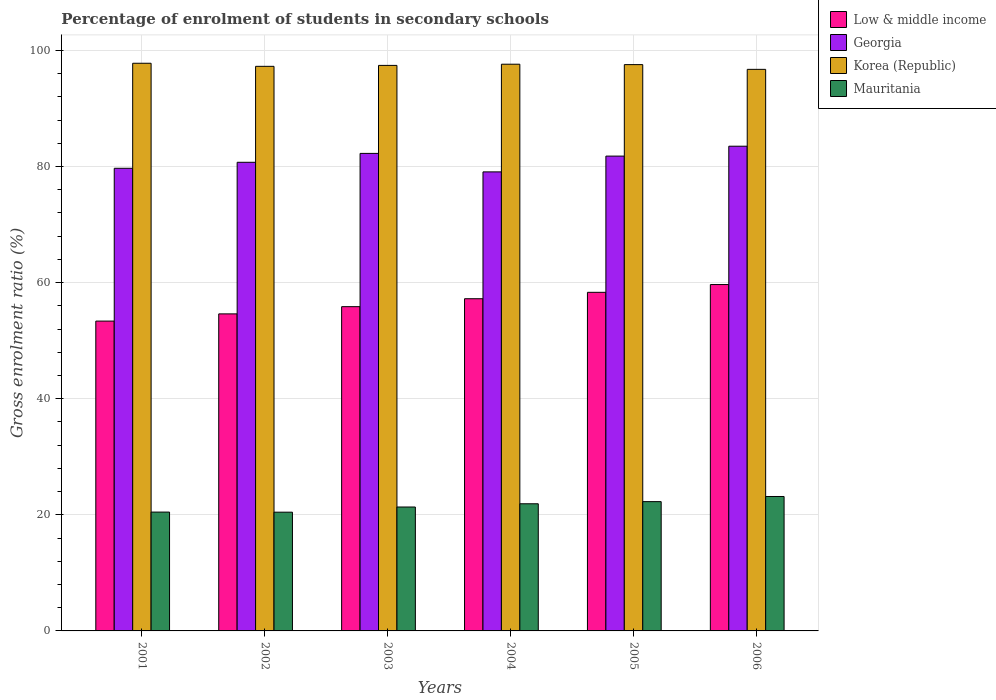Are the number of bars on each tick of the X-axis equal?
Your answer should be very brief. Yes. How many bars are there on the 4th tick from the right?
Make the answer very short. 4. In how many cases, is the number of bars for a given year not equal to the number of legend labels?
Make the answer very short. 0. What is the percentage of students enrolled in secondary schools in Korea (Republic) in 2002?
Your response must be concise. 97.24. Across all years, what is the maximum percentage of students enrolled in secondary schools in Mauritania?
Offer a terse response. 23.15. Across all years, what is the minimum percentage of students enrolled in secondary schools in Mauritania?
Make the answer very short. 20.45. In which year was the percentage of students enrolled in secondary schools in Low & middle income minimum?
Provide a short and direct response. 2001. What is the total percentage of students enrolled in secondary schools in Mauritania in the graph?
Your answer should be compact. 129.58. What is the difference between the percentage of students enrolled in secondary schools in Mauritania in 2003 and that in 2004?
Ensure brevity in your answer.  -0.56. What is the difference between the percentage of students enrolled in secondary schools in Mauritania in 2001 and the percentage of students enrolled in secondary schools in Korea (Republic) in 2006?
Give a very brief answer. -76.26. What is the average percentage of students enrolled in secondary schools in Mauritania per year?
Offer a very short reply. 21.6. In the year 2001, what is the difference between the percentage of students enrolled in secondary schools in Mauritania and percentage of students enrolled in secondary schools in Low & middle income?
Provide a short and direct response. -32.9. In how many years, is the percentage of students enrolled in secondary schools in Mauritania greater than 40 %?
Offer a very short reply. 0. What is the ratio of the percentage of students enrolled in secondary schools in Korea (Republic) in 2003 to that in 2006?
Provide a succinct answer. 1.01. What is the difference between the highest and the second highest percentage of students enrolled in secondary schools in Korea (Republic)?
Give a very brief answer. 0.16. What is the difference between the highest and the lowest percentage of students enrolled in secondary schools in Low & middle income?
Give a very brief answer. 6.29. In how many years, is the percentage of students enrolled in secondary schools in Korea (Republic) greater than the average percentage of students enrolled in secondary schools in Korea (Republic) taken over all years?
Your response must be concise. 4. Is the sum of the percentage of students enrolled in secondary schools in Low & middle income in 2003 and 2006 greater than the maximum percentage of students enrolled in secondary schools in Korea (Republic) across all years?
Give a very brief answer. Yes. Is it the case that in every year, the sum of the percentage of students enrolled in secondary schools in Mauritania and percentage of students enrolled in secondary schools in Korea (Republic) is greater than the sum of percentage of students enrolled in secondary schools in Georgia and percentage of students enrolled in secondary schools in Low & middle income?
Give a very brief answer. Yes. What does the 4th bar from the left in 2001 represents?
Give a very brief answer. Mauritania. What does the 1st bar from the right in 2003 represents?
Keep it short and to the point. Mauritania. Is it the case that in every year, the sum of the percentage of students enrolled in secondary schools in Georgia and percentage of students enrolled in secondary schools in Mauritania is greater than the percentage of students enrolled in secondary schools in Low & middle income?
Make the answer very short. Yes. Are all the bars in the graph horizontal?
Your answer should be very brief. No. How many years are there in the graph?
Provide a succinct answer. 6. What is the difference between two consecutive major ticks on the Y-axis?
Provide a short and direct response. 20. Where does the legend appear in the graph?
Ensure brevity in your answer.  Top right. How many legend labels are there?
Keep it short and to the point. 4. What is the title of the graph?
Your answer should be very brief. Percentage of enrolment of students in secondary schools. What is the Gross enrolment ratio (%) of Low & middle income in 2001?
Make the answer very short. 53.37. What is the Gross enrolment ratio (%) of Georgia in 2001?
Your answer should be very brief. 79.68. What is the Gross enrolment ratio (%) in Korea (Republic) in 2001?
Offer a terse response. 97.77. What is the Gross enrolment ratio (%) in Mauritania in 2001?
Offer a very short reply. 20.47. What is the Gross enrolment ratio (%) of Low & middle income in 2002?
Offer a terse response. 54.61. What is the Gross enrolment ratio (%) of Georgia in 2002?
Your answer should be compact. 80.72. What is the Gross enrolment ratio (%) in Korea (Republic) in 2002?
Ensure brevity in your answer.  97.24. What is the Gross enrolment ratio (%) in Mauritania in 2002?
Ensure brevity in your answer.  20.45. What is the Gross enrolment ratio (%) of Low & middle income in 2003?
Your response must be concise. 55.85. What is the Gross enrolment ratio (%) in Georgia in 2003?
Your answer should be very brief. 82.25. What is the Gross enrolment ratio (%) of Korea (Republic) in 2003?
Ensure brevity in your answer.  97.4. What is the Gross enrolment ratio (%) of Mauritania in 2003?
Provide a short and direct response. 21.34. What is the Gross enrolment ratio (%) in Low & middle income in 2004?
Give a very brief answer. 57.22. What is the Gross enrolment ratio (%) of Georgia in 2004?
Offer a terse response. 79.06. What is the Gross enrolment ratio (%) in Korea (Republic) in 2004?
Provide a short and direct response. 97.61. What is the Gross enrolment ratio (%) of Mauritania in 2004?
Ensure brevity in your answer.  21.9. What is the Gross enrolment ratio (%) of Low & middle income in 2005?
Ensure brevity in your answer.  58.32. What is the Gross enrolment ratio (%) in Georgia in 2005?
Provide a short and direct response. 81.78. What is the Gross enrolment ratio (%) of Korea (Republic) in 2005?
Give a very brief answer. 97.54. What is the Gross enrolment ratio (%) in Mauritania in 2005?
Keep it short and to the point. 22.27. What is the Gross enrolment ratio (%) of Low & middle income in 2006?
Provide a short and direct response. 59.66. What is the Gross enrolment ratio (%) of Georgia in 2006?
Offer a very short reply. 83.49. What is the Gross enrolment ratio (%) of Korea (Republic) in 2006?
Make the answer very short. 96.72. What is the Gross enrolment ratio (%) in Mauritania in 2006?
Give a very brief answer. 23.15. Across all years, what is the maximum Gross enrolment ratio (%) in Low & middle income?
Provide a short and direct response. 59.66. Across all years, what is the maximum Gross enrolment ratio (%) in Georgia?
Your answer should be compact. 83.49. Across all years, what is the maximum Gross enrolment ratio (%) of Korea (Republic)?
Provide a short and direct response. 97.77. Across all years, what is the maximum Gross enrolment ratio (%) of Mauritania?
Offer a very short reply. 23.15. Across all years, what is the minimum Gross enrolment ratio (%) of Low & middle income?
Your answer should be very brief. 53.37. Across all years, what is the minimum Gross enrolment ratio (%) in Georgia?
Keep it short and to the point. 79.06. Across all years, what is the minimum Gross enrolment ratio (%) of Korea (Republic)?
Provide a succinct answer. 96.72. Across all years, what is the minimum Gross enrolment ratio (%) of Mauritania?
Offer a terse response. 20.45. What is the total Gross enrolment ratio (%) in Low & middle income in the graph?
Give a very brief answer. 339.02. What is the total Gross enrolment ratio (%) in Georgia in the graph?
Give a very brief answer. 486.98. What is the total Gross enrolment ratio (%) of Korea (Republic) in the graph?
Provide a succinct answer. 584.29. What is the total Gross enrolment ratio (%) of Mauritania in the graph?
Make the answer very short. 129.58. What is the difference between the Gross enrolment ratio (%) of Low & middle income in 2001 and that in 2002?
Ensure brevity in your answer.  -1.24. What is the difference between the Gross enrolment ratio (%) of Georgia in 2001 and that in 2002?
Keep it short and to the point. -1.04. What is the difference between the Gross enrolment ratio (%) of Korea (Republic) in 2001 and that in 2002?
Keep it short and to the point. 0.53. What is the difference between the Gross enrolment ratio (%) in Mauritania in 2001 and that in 2002?
Provide a short and direct response. 0.02. What is the difference between the Gross enrolment ratio (%) in Low & middle income in 2001 and that in 2003?
Make the answer very short. -2.48. What is the difference between the Gross enrolment ratio (%) of Georgia in 2001 and that in 2003?
Make the answer very short. -2.57. What is the difference between the Gross enrolment ratio (%) of Korea (Republic) in 2001 and that in 2003?
Make the answer very short. 0.37. What is the difference between the Gross enrolment ratio (%) in Mauritania in 2001 and that in 2003?
Ensure brevity in your answer.  -0.87. What is the difference between the Gross enrolment ratio (%) in Low & middle income in 2001 and that in 2004?
Provide a short and direct response. -3.85. What is the difference between the Gross enrolment ratio (%) of Georgia in 2001 and that in 2004?
Your answer should be very brief. 0.62. What is the difference between the Gross enrolment ratio (%) of Korea (Republic) in 2001 and that in 2004?
Ensure brevity in your answer.  0.16. What is the difference between the Gross enrolment ratio (%) of Mauritania in 2001 and that in 2004?
Provide a short and direct response. -1.43. What is the difference between the Gross enrolment ratio (%) in Low & middle income in 2001 and that in 2005?
Make the answer very short. -4.95. What is the difference between the Gross enrolment ratio (%) in Georgia in 2001 and that in 2005?
Offer a terse response. -2.1. What is the difference between the Gross enrolment ratio (%) of Korea (Republic) in 2001 and that in 2005?
Make the answer very short. 0.23. What is the difference between the Gross enrolment ratio (%) of Mauritania in 2001 and that in 2005?
Offer a terse response. -1.8. What is the difference between the Gross enrolment ratio (%) in Low & middle income in 2001 and that in 2006?
Offer a terse response. -6.29. What is the difference between the Gross enrolment ratio (%) of Georgia in 2001 and that in 2006?
Give a very brief answer. -3.8. What is the difference between the Gross enrolment ratio (%) of Korea (Republic) in 2001 and that in 2006?
Ensure brevity in your answer.  1.05. What is the difference between the Gross enrolment ratio (%) in Mauritania in 2001 and that in 2006?
Make the answer very short. -2.68. What is the difference between the Gross enrolment ratio (%) in Low & middle income in 2002 and that in 2003?
Make the answer very short. -1.24. What is the difference between the Gross enrolment ratio (%) in Georgia in 2002 and that in 2003?
Give a very brief answer. -1.53. What is the difference between the Gross enrolment ratio (%) of Korea (Republic) in 2002 and that in 2003?
Your answer should be compact. -0.16. What is the difference between the Gross enrolment ratio (%) in Mauritania in 2002 and that in 2003?
Keep it short and to the point. -0.89. What is the difference between the Gross enrolment ratio (%) of Low & middle income in 2002 and that in 2004?
Make the answer very short. -2.61. What is the difference between the Gross enrolment ratio (%) of Georgia in 2002 and that in 2004?
Your response must be concise. 1.65. What is the difference between the Gross enrolment ratio (%) of Korea (Republic) in 2002 and that in 2004?
Keep it short and to the point. -0.37. What is the difference between the Gross enrolment ratio (%) of Mauritania in 2002 and that in 2004?
Offer a terse response. -1.45. What is the difference between the Gross enrolment ratio (%) in Low & middle income in 2002 and that in 2005?
Provide a short and direct response. -3.71. What is the difference between the Gross enrolment ratio (%) in Georgia in 2002 and that in 2005?
Give a very brief answer. -1.07. What is the difference between the Gross enrolment ratio (%) in Korea (Republic) in 2002 and that in 2005?
Keep it short and to the point. -0.3. What is the difference between the Gross enrolment ratio (%) of Mauritania in 2002 and that in 2005?
Make the answer very short. -1.82. What is the difference between the Gross enrolment ratio (%) in Low & middle income in 2002 and that in 2006?
Give a very brief answer. -5.05. What is the difference between the Gross enrolment ratio (%) of Georgia in 2002 and that in 2006?
Give a very brief answer. -2.77. What is the difference between the Gross enrolment ratio (%) in Korea (Republic) in 2002 and that in 2006?
Your answer should be compact. 0.52. What is the difference between the Gross enrolment ratio (%) of Mauritania in 2002 and that in 2006?
Give a very brief answer. -2.7. What is the difference between the Gross enrolment ratio (%) in Low & middle income in 2003 and that in 2004?
Your response must be concise. -1.37. What is the difference between the Gross enrolment ratio (%) in Georgia in 2003 and that in 2004?
Your answer should be very brief. 3.19. What is the difference between the Gross enrolment ratio (%) in Korea (Republic) in 2003 and that in 2004?
Offer a terse response. -0.2. What is the difference between the Gross enrolment ratio (%) in Mauritania in 2003 and that in 2004?
Provide a short and direct response. -0.56. What is the difference between the Gross enrolment ratio (%) in Low & middle income in 2003 and that in 2005?
Ensure brevity in your answer.  -2.47. What is the difference between the Gross enrolment ratio (%) of Georgia in 2003 and that in 2005?
Your answer should be compact. 0.47. What is the difference between the Gross enrolment ratio (%) in Korea (Republic) in 2003 and that in 2005?
Offer a terse response. -0.13. What is the difference between the Gross enrolment ratio (%) of Mauritania in 2003 and that in 2005?
Your answer should be very brief. -0.93. What is the difference between the Gross enrolment ratio (%) of Low & middle income in 2003 and that in 2006?
Make the answer very short. -3.81. What is the difference between the Gross enrolment ratio (%) of Georgia in 2003 and that in 2006?
Offer a terse response. -1.24. What is the difference between the Gross enrolment ratio (%) in Korea (Republic) in 2003 and that in 2006?
Keep it short and to the point. 0.68. What is the difference between the Gross enrolment ratio (%) of Mauritania in 2003 and that in 2006?
Make the answer very short. -1.81. What is the difference between the Gross enrolment ratio (%) of Low & middle income in 2004 and that in 2005?
Provide a short and direct response. -1.1. What is the difference between the Gross enrolment ratio (%) in Georgia in 2004 and that in 2005?
Ensure brevity in your answer.  -2.72. What is the difference between the Gross enrolment ratio (%) of Korea (Republic) in 2004 and that in 2005?
Make the answer very short. 0.07. What is the difference between the Gross enrolment ratio (%) of Mauritania in 2004 and that in 2005?
Your response must be concise. -0.37. What is the difference between the Gross enrolment ratio (%) of Low & middle income in 2004 and that in 2006?
Provide a succinct answer. -2.44. What is the difference between the Gross enrolment ratio (%) of Georgia in 2004 and that in 2006?
Offer a very short reply. -4.42. What is the difference between the Gross enrolment ratio (%) of Korea (Republic) in 2004 and that in 2006?
Make the answer very short. 0.88. What is the difference between the Gross enrolment ratio (%) in Mauritania in 2004 and that in 2006?
Offer a very short reply. -1.25. What is the difference between the Gross enrolment ratio (%) in Low & middle income in 2005 and that in 2006?
Provide a succinct answer. -1.34. What is the difference between the Gross enrolment ratio (%) of Georgia in 2005 and that in 2006?
Offer a very short reply. -1.7. What is the difference between the Gross enrolment ratio (%) of Korea (Republic) in 2005 and that in 2006?
Make the answer very short. 0.81. What is the difference between the Gross enrolment ratio (%) in Mauritania in 2005 and that in 2006?
Your answer should be very brief. -0.89. What is the difference between the Gross enrolment ratio (%) in Low & middle income in 2001 and the Gross enrolment ratio (%) in Georgia in 2002?
Give a very brief answer. -27.35. What is the difference between the Gross enrolment ratio (%) in Low & middle income in 2001 and the Gross enrolment ratio (%) in Korea (Republic) in 2002?
Offer a very short reply. -43.88. What is the difference between the Gross enrolment ratio (%) in Low & middle income in 2001 and the Gross enrolment ratio (%) in Mauritania in 2002?
Offer a very short reply. 32.91. What is the difference between the Gross enrolment ratio (%) in Georgia in 2001 and the Gross enrolment ratio (%) in Korea (Republic) in 2002?
Ensure brevity in your answer.  -17.56. What is the difference between the Gross enrolment ratio (%) in Georgia in 2001 and the Gross enrolment ratio (%) in Mauritania in 2002?
Provide a short and direct response. 59.23. What is the difference between the Gross enrolment ratio (%) of Korea (Republic) in 2001 and the Gross enrolment ratio (%) of Mauritania in 2002?
Provide a succinct answer. 77.32. What is the difference between the Gross enrolment ratio (%) of Low & middle income in 2001 and the Gross enrolment ratio (%) of Georgia in 2003?
Provide a succinct answer. -28.88. What is the difference between the Gross enrolment ratio (%) in Low & middle income in 2001 and the Gross enrolment ratio (%) in Korea (Republic) in 2003?
Ensure brevity in your answer.  -44.04. What is the difference between the Gross enrolment ratio (%) in Low & middle income in 2001 and the Gross enrolment ratio (%) in Mauritania in 2003?
Give a very brief answer. 32.02. What is the difference between the Gross enrolment ratio (%) in Georgia in 2001 and the Gross enrolment ratio (%) in Korea (Republic) in 2003?
Provide a succinct answer. -17.72. What is the difference between the Gross enrolment ratio (%) of Georgia in 2001 and the Gross enrolment ratio (%) of Mauritania in 2003?
Keep it short and to the point. 58.34. What is the difference between the Gross enrolment ratio (%) in Korea (Republic) in 2001 and the Gross enrolment ratio (%) in Mauritania in 2003?
Your answer should be very brief. 76.43. What is the difference between the Gross enrolment ratio (%) in Low & middle income in 2001 and the Gross enrolment ratio (%) in Georgia in 2004?
Give a very brief answer. -25.7. What is the difference between the Gross enrolment ratio (%) of Low & middle income in 2001 and the Gross enrolment ratio (%) of Korea (Republic) in 2004?
Ensure brevity in your answer.  -44.24. What is the difference between the Gross enrolment ratio (%) in Low & middle income in 2001 and the Gross enrolment ratio (%) in Mauritania in 2004?
Give a very brief answer. 31.47. What is the difference between the Gross enrolment ratio (%) in Georgia in 2001 and the Gross enrolment ratio (%) in Korea (Republic) in 2004?
Provide a succinct answer. -17.93. What is the difference between the Gross enrolment ratio (%) in Georgia in 2001 and the Gross enrolment ratio (%) in Mauritania in 2004?
Keep it short and to the point. 57.78. What is the difference between the Gross enrolment ratio (%) of Korea (Republic) in 2001 and the Gross enrolment ratio (%) of Mauritania in 2004?
Provide a short and direct response. 75.87. What is the difference between the Gross enrolment ratio (%) of Low & middle income in 2001 and the Gross enrolment ratio (%) of Georgia in 2005?
Your answer should be very brief. -28.42. What is the difference between the Gross enrolment ratio (%) in Low & middle income in 2001 and the Gross enrolment ratio (%) in Korea (Republic) in 2005?
Your response must be concise. -44.17. What is the difference between the Gross enrolment ratio (%) in Low & middle income in 2001 and the Gross enrolment ratio (%) in Mauritania in 2005?
Keep it short and to the point. 31.1. What is the difference between the Gross enrolment ratio (%) of Georgia in 2001 and the Gross enrolment ratio (%) of Korea (Republic) in 2005?
Offer a very short reply. -17.86. What is the difference between the Gross enrolment ratio (%) of Georgia in 2001 and the Gross enrolment ratio (%) of Mauritania in 2005?
Make the answer very short. 57.41. What is the difference between the Gross enrolment ratio (%) of Korea (Republic) in 2001 and the Gross enrolment ratio (%) of Mauritania in 2005?
Your answer should be compact. 75.51. What is the difference between the Gross enrolment ratio (%) of Low & middle income in 2001 and the Gross enrolment ratio (%) of Georgia in 2006?
Keep it short and to the point. -30.12. What is the difference between the Gross enrolment ratio (%) of Low & middle income in 2001 and the Gross enrolment ratio (%) of Korea (Republic) in 2006?
Keep it short and to the point. -43.36. What is the difference between the Gross enrolment ratio (%) of Low & middle income in 2001 and the Gross enrolment ratio (%) of Mauritania in 2006?
Provide a succinct answer. 30.21. What is the difference between the Gross enrolment ratio (%) of Georgia in 2001 and the Gross enrolment ratio (%) of Korea (Republic) in 2006?
Your answer should be very brief. -17.04. What is the difference between the Gross enrolment ratio (%) of Georgia in 2001 and the Gross enrolment ratio (%) of Mauritania in 2006?
Give a very brief answer. 56.53. What is the difference between the Gross enrolment ratio (%) in Korea (Republic) in 2001 and the Gross enrolment ratio (%) in Mauritania in 2006?
Offer a very short reply. 74.62. What is the difference between the Gross enrolment ratio (%) of Low & middle income in 2002 and the Gross enrolment ratio (%) of Georgia in 2003?
Keep it short and to the point. -27.64. What is the difference between the Gross enrolment ratio (%) of Low & middle income in 2002 and the Gross enrolment ratio (%) of Korea (Republic) in 2003?
Your response must be concise. -42.8. What is the difference between the Gross enrolment ratio (%) of Low & middle income in 2002 and the Gross enrolment ratio (%) of Mauritania in 2003?
Make the answer very short. 33.26. What is the difference between the Gross enrolment ratio (%) in Georgia in 2002 and the Gross enrolment ratio (%) in Korea (Republic) in 2003?
Make the answer very short. -16.69. What is the difference between the Gross enrolment ratio (%) in Georgia in 2002 and the Gross enrolment ratio (%) in Mauritania in 2003?
Offer a terse response. 59.37. What is the difference between the Gross enrolment ratio (%) in Korea (Republic) in 2002 and the Gross enrolment ratio (%) in Mauritania in 2003?
Make the answer very short. 75.9. What is the difference between the Gross enrolment ratio (%) of Low & middle income in 2002 and the Gross enrolment ratio (%) of Georgia in 2004?
Make the answer very short. -24.46. What is the difference between the Gross enrolment ratio (%) of Low & middle income in 2002 and the Gross enrolment ratio (%) of Korea (Republic) in 2004?
Your response must be concise. -43. What is the difference between the Gross enrolment ratio (%) of Low & middle income in 2002 and the Gross enrolment ratio (%) of Mauritania in 2004?
Ensure brevity in your answer.  32.71. What is the difference between the Gross enrolment ratio (%) in Georgia in 2002 and the Gross enrolment ratio (%) in Korea (Republic) in 2004?
Your answer should be very brief. -16.89. What is the difference between the Gross enrolment ratio (%) in Georgia in 2002 and the Gross enrolment ratio (%) in Mauritania in 2004?
Provide a succinct answer. 58.82. What is the difference between the Gross enrolment ratio (%) in Korea (Republic) in 2002 and the Gross enrolment ratio (%) in Mauritania in 2004?
Offer a terse response. 75.34. What is the difference between the Gross enrolment ratio (%) in Low & middle income in 2002 and the Gross enrolment ratio (%) in Georgia in 2005?
Keep it short and to the point. -27.18. What is the difference between the Gross enrolment ratio (%) in Low & middle income in 2002 and the Gross enrolment ratio (%) in Korea (Republic) in 2005?
Give a very brief answer. -42.93. What is the difference between the Gross enrolment ratio (%) in Low & middle income in 2002 and the Gross enrolment ratio (%) in Mauritania in 2005?
Keep it short and to the point. 32.34. What is the difference between the Gross enrolment ratio (%) in Georgia in 2002 and the Gross enrolment ratio (%) in Korea (Republic) in 2005?
Make the answer very short. -16.82. What is the difference between the Gross enrolment ratio (%) of Georgia in 2002 and the Gross enrolment ratio (%) of Mauritania in 2005?
Your answer should be compact. 58.45. What is the difference between the Gross enrolment ratio (%) of Korea (Republic) in 2002 and the Gross enrolment ratio (%) of Mauritania in 2005?
Provide a short and direct response. 74.98. What is the difference between the Gross enrolment ratio (%) of Low & middle income in 2002 and the Gross enrolment ratio (%) of Georgia in 2006?
Offer a very short reply. -28.88. What is the difference between the Gross enrolment ratio (%) in Low & middle income in 2002 and the Gross enrolment ratio (%) in Korea (Republic) in 2006?
Your answer should be very brief. -42.12. What is the difference between the Gross enrolment ratio (%) of Low & middle income in 2002 and the Gross enrolment ratio (%) of Mauritania in 2006?
Keep it short and to the point. 31.45. What is the difference between the Gross enrolment ratio (%) of Georgia in 2002 and the Gross enrolment ratio (%) of Korea (Republic) in 2006?
Your response must be concise. -16.01. What is the difference between the Gross enrolment ratio (%) of Georgia in 2002 and the Gross enrolment ratio (%) of Mauritania in 2006?
Your answer should be very brief. 57.56. What is the difference between the Gross enrolment ratio (%) in Korea (Republic) in 2002 and the Gross enrolment ratio (%) in Mauritania in 2006?
Provide a succinct answer. 74.09. What is the difference between the Gross enrolment ratio (%) in Low & middle income in 2003 and the Gross enrolment ratio (%) in Georgia in 2004?
Your answer should be very brief. -23.21. What is the difference between the Gross enrolment ratio (%) of Low & middle income in 2003 and the Gross enrolment ratio (%) of Korea (Republic) in 2004?
Your response must be concise. -41.76. What is the difference between the Gross enrolment ratio (%) of Low & middle income in 2003 and the Gross enrolment ratio (%) of Mauritania in 2004?
Provide a succinct answer. 33.95. What is the difference between the Gross enrolment ratio (%) of Georgia in 2003 and the Gross enrolment ratio (%) of Korea (Republic) in 2004?
Provide a short and direct response. -15.36. What is the difference between the Gross enrolment ratio (%) in Georgia in 2003 and the Gross enrolment ratio (%) in Mauritania in 2004?
Your response must be concise. 60.35. What is the difference between the Gross enrolment ratio (%) of Korea (Republic) in 2003 and the Gross enrolment ratio (%) of Mauritania in 2004?
Ensure brevity in your answer.  75.51. What is the difference between the Gross enrolment ratio (%) of Low & middle income in 2003 and the Gross enrolment ratio (%) of Georgia in 2005?
Offer a very short reply. -25.93. What is the difference between the Gross enrolment ratio (%) of Low & middle income in 2003 and the Gross enrolment ratio (%) of Korea (Republic) in 2005?
Provide a short and direct response. -41.69. What is the difference between the Gross enrolment ratio (%) of Low & middle income in 2003 and the Gross enrolment ratio (%) of Mauritania in 2005?
Your answer should be compact. 33.58. What is the difference between the Gross enrolment ratio (%) of Georgia in 2003 and the Gross enrolment ratio (%) of Korea (Republic) in 2005?
Make the answer very short. -15.29. What is the difference between the Gross enrolment ratio (%) of Georgia in 2003 and the Gross enrolment ratio (%) of Mauritania in 2005?
Give a very brief answer. 59.98. What is the difference between the Gross enrolment ratio (%) of Korea (Republic) in 2003 and the Gross enrolment ratio (%) of Mauritania in 2005?
Keep it short and to the point. 75.14. What is the difference between the Gross enrolment ratio (%) in Low & middle income in 2003 and the Gross enrolment ratio (%) in Georgia in 2006?
Provide a short and direct response. -27.64. What is the difference between the Gross enrolment ratio (%) in Low & middle income in 2003 and the Gross enrolment ratio (%) in Korea (Republic) in 2006?
Make the answer very short. -40.88. What is the difference between the Gross enrolment ratio (%) of Low & middle income in 2003 and the Gross enrolment ratio (%) of Mauritania in 2006?
Keep it short and to the point. 32.7. What is the difference between the Gross enrolment ratio (%) in Georgia in 2003 and the Gross enrolment ratio (%) in Korea (Republic) in 2006?
Keep it short and to the point. -14.48. What is the difference between the Gross enrolment ratio (%) in Georgia in 2003 and the Gross enrolment ratio (%) in Mauritania in 2006?
Offer a very short reply. 59.1. What is the difference between the Gross enrolment ratio (%) of Korea (Republic) in 2003 and the Gross enrolment ratio (%) of Mauritania in 2006?
Give a very brief answer. 74.25. What is the difference between the Gross enrolment ratio (%) of Low & middle income in 2004 and the Gross enrolment ratio (%) of Georgia in 2005?
Your response must be concise. -24.56. What is the difference between the Gross enrolment ratio (%) in Low & middle income in 2004 and the Gross enrolment ratio (%) in Korea (Republic) in 2005?
Make the answer very short. -40.32. What is the difference between the Gross enrolment ratio (%) of Low & middle income in 2004 and the Gross enrolment ratio (%) of Mauritania in 2005?
Ensure brevity in your answer.  34.95. What is the difference between the Gross enrolment ratio (%) of Georgia in 2004 and the Gross enrolment ratio (%) of Korea (Republic) in 2005?
Keep it short and to the point. -18.48. What is the difference between the Gross enrolment ratio (%) in Georgia in 2004 and the Gross enrolment ratio (%) in Mauritania in 2005?
Make the answer very short. 56.8. What is the difference between the Gross enrolment ratio (%) of Korea (Republic) in 2004 and the Gross enrolment ratio (%) of Mauritania in 2005?
Your answer should be very brief. 75.34. What is the difference between the Gross enrolment ratio (%) in Low & middle income in 2004 and the Gross enrolment ratio (%) in Georgia in 2006?
Ensure brevity in your answer.  -26.27. What is the difference between the Gross enrolment ratio (%) in Low & middle income in 2004 and the Gross enrolment ratio (%) in Korea (Republic) in 2006?
Make the answer very short. -39.51. What is the difference between the Gross enrolment ratio (%) of Low & middle income in 2004 and the Gross enrolment ratio (%) of Mauritania in 2006?
Provide a short and direct response. 34.06. What is the difference between the Gross enrolment ratio (%) of Georgia in 2004 and the Gross enrolment ratio (%) of Korea (Republic) in 2006?
Give a very brief answer. -17.66. What is the difference between the Gross enrolment ratio (%) in Georgia in 2004 and the Gross enrolment ratio (%) in Mauritania in 2006?
Provide a short and direct response. 55.91. What is the difference between the Gross enrolment ratio (%) of Korea (Republic) in 2004 and the Gross enrolment ratio (%) of Mauritania in 2006?
Provide a succinct answer. 74.46. What is the difference between the Gross enrolment ratio (%) in Low & middle income in 2005 and the Gross enrolment ratio (%) in Georgia in 2006?
Provide a short and direct response. -25.17. What is the difference between the Gross enrolment ratio (%) in Low & middle income in 2005 and the Gross enrolment ratio (%) in Korea (Republic) in 2006?
Ensure brevity in your answer.  -38.4. What is the difference between the Gross enrolment ratio (%) in Low & middle income in 2005 and the Gross enrolment ratio (%) in Mauritania in 2006?
Your answer should be compact. 35.17. What is the difference between the Gross enrolment ratio (%) in Georgia in 2005 and the Gross enrolment ratio (%) in Korea (Republic) in 2006?
Ensure brevity in your answer.  -14.94. What is the difference between the Gross enrolment ratio (%) of Georgia in 2005 and the Gross enrolment ratio (%) of Mauritania in 2006?
Your answer should be compact. 58.63. What is the difference between the Gross enrolment ratio (%) of Korea (Republic) in 2005 and the Gross enrolment ratio (%) of Mauritania in 2006?
Ensure brevity in your answer.  74.39. What is the average Gross enrolment ratio (%) of Low & middle income per year?
Offer a very short reply. 56.5. What is the average Gross enrolment ratio (%) in Georgia per year?
Your answer should be very brief. 81.16. What is the average Gross enrolment ratio (%) of Korea (Republic) per year?
Your answer should be compact. 97.38. What is the average Gross enrolment ratio (%) of Mauritania per year?
Your answer should be compact. 21.6. In the year 2001, what is the difference between the Gross enrolment ratio (%) of Low & middle income and Gross enrolment ratio (%) of Georgia?
Keep it short and to the point. -26.32. In the year 2001, what is the difference between the Gross enrolment ratio (%) in Low & middle income and Gross enrolment ratio (%) in Korea (Republic)?
Offer a very short reply. -44.41. In the year 2001, what is the difference between the Gross enrolment ratio (%) of Low & middle income and Gross enrolment ratio (%) of Mauritania?
Offer a terse response. 32.9. In the year 2001, what is the difference between the Gross enrolment ratio (%) of Georgia and Gross enrolment ratio (%) of Korea (Republic)?
Make the answer very short. -18.09. In the year 2001, what is the difference between the Gross enrolment ratio (%) in Georgia and Gross enrolment ratio (%) in Mauritania?
Provide a short and direct response. 59.21. In the year 2001, what is the difference between the Gross enrolment ratio (%) in Korea (Republic) and Gross enrolment ratio (%) in Mauritania?
Keep it short and to the point. 77.3. In the year 2002, what is the difference between the Gross enrolment ratio (%) of Low & middle income and Gross enrolment ratio (%) of Georgia?
Provide a succinct answer. -26.11. In the year 2002, what is the difference between the Gross enrolment ratio (%) in Low & middle income and Gross enrolment ratio (%) in Korea (Republic)?
Offer a terse response. -42.64. In the year 2002, what is the difference between the Gross enrolment ratio (%) in Low & middle income and Gross enrolment ratio (%) in Mauritania?
Ensure brevity in your answer.  34.15. In the year 2002, what is the difference between the Gross enrolment ratio (%) of Georgia and Gross enrolment ratio (%) of Korea (Republic)?
Give a very brief answer. -16.53. In the year 2002, what is the difference between the Gross enrolment ratio (%) in Georgia and Gross enrolment ratio (%) in Mauritania?
Provide a succinct answer. 60.27. In the year 2002, what is the difference between the Gross enrolment ratio (%) of Korea (Republic) and Gross enrolment ratio (%) of Mauritania?
Your answer should be very brief. 76.79. In the year 2003, what is the difference between the Gross enrolment ratio (%) in Low & middle income and Gross enrolment ratio (%) in Georgia?
Your response must be concise. -26.4. In the year 2003, what is the difference between the Gross enrolment ratio (%) in Low & middle income and Gross enrolment ratio (%) in Korea (Republic)?
Give a very brief answer. -41.56. In the year 2003, what is the difference between the Gross enrolment ratio (%) of Low & middle income and Gross enrolment ratio (%) of Mauritania?
Provide a succinct answer. 34.51. In the year 2003, what is the difference between the Gross enrolment ratio (%) of Georgia and Gross enrolment ratio (%) of Korea (Republic)?
Give a very brief answer. -15.16. In the year 2003, what is the difference between the Gross enrolment ratio (%) in Georgia and Gross enrolment ratio (%) in Mauritania?
Your answer should be compact. 60.91. In the year 2003, what is the difference between the Gross enrolment ratio (%) of Korea (Republic) and Gross enrolment ratio (%) of Mauritania?
Provide a succinct answer. 76.06. In the year 2004, what is the difference between the Gross enrolment ratio (%) in Low & middle income and Gross enrolment ratio (%) in Georgia?
Give a very brief answer. -21.85. In the year 2004, what is the difference between the Gross enrolment ratio (%) in Low & middle income and Gross enrolment ratio (%) in Korea (Republic)?
Your response must be concise. -40.39. In the year 2004, what is the difference between the Gross enrolment ratio (%) in Low & middle income and Gross enrolment ratio (%) in Mauritania?
Keep it short and to the point. 35.32. In the year 2004, what is the difference between the Gross enrolment ratio (%) in Georgia and Gross enrolment ratio (%) in Korea (Republic)?
Your response must be concise. -18.55. In the year 2004, what is the difference between the Gross enrolment ratio (%) in Georgia and Gross enrolment ratio (%) in Mauritania?
Make the answer very short. 57.16. In the year 2004, what is the difference between the Gross enrolment ratio (%) in Korea (Republic) and Gross enrolment ratio (%) in Mauritania?
Your answer should be compact. 75.71. In the year 2005, what is the difference between the Gross enrolment ratio (%) of Low & middle income and Gross enrolment ratio (%) of Georgia?
Ensure brevity in your answer.  -23.46. In the year 2005, what is the difference between the Gross enrolment ratio (%) in Low & middle income and Gross enrolment ratio (%) in Korea (Republic)?
Ensure brevity in your answer.  -39.22. In the year 2005, what is the difference between the Gross enrolment ratio (%) of Low & middle income and Gross enrolment ratio (%) of Mauritania?
Provide a succinct answer. 36.05. In the year 2005, what is the difference between the Gross enrolment ratio (%) in Georgia and Gross enrolment ratio (%) in Korea (Republic)?
Provide a short and direct response. -15.76. In the year 2005, what is the difference between the Gross enrolment ratio (%) in Georgia and Gross enrolment ratio (%) in Mauritania?
Offer a terse response. 59.51. In the year 2005, what is the difference between the Gross enrolment ratio (%) in Korea (Republic) and Gross enrolment ratio (%) in Mauritania?
Provide a short and direct response. 75.27. In the year 2006, what is the difference between the Gross enrolment ratio (%) of Low & middle income and Gross enrolment ratio (%) of Georgia?
Keep it short and to the point. -23.83. In the year 2006, what is the difference between the Gross enrolment ratio (%) of Low & middle income and Gross enrolment ratio (%) of Korea (Republic)?
Keep it short and to the point. -37.07. In the year 2006, what is the difference between the Gross enrolment ratio (%) in Low & middle income and Gross enrolment ratio (%) in Mauritania?
Provide a succinct answer. 36.51. In the year 2006, what is the difference between the Gross enrolment ratio (%) of Georgia and Gross enrolment ratio (%) of Korea (Republic)?
Offer a very short reply. -13.24. In the year 2006, what is the difference between the Gross enrolment ratio (%) in Georgia and Gross enrolment ratio (%) in Mauritania?
Ensure brevity in your answer.  60.33. In the year 2006, what is the difference between the Gross enrolment ratio (%) of Korea (Republic) and Gross enrolment ratio (%) of Mauritania?
Offer a very short reply. 73.57. What is the ratio of the Gross enrolment ratio (%) in Low & middle income in 2001 to that in 2002?
Keep it short and to the point. 0.98. What is the ratio of the Gross enrolment ratio (%) of Georgia in 2001 to that in 2002?
Provide a succinct answer. 0.99. What is the ratio of the Gross enrolment ratio (%) in Mauritania in 2001 to that in 2002?
Keep it short and to the point. 1. What is the ratio of the Gross enrolment ratio (%) of Low & middle income in 2001 to that in 2003?
Provide a short and direct response. 0.96. What is the ratio of the Gross enrolment ratio (%) of Georgia in 2001 to that in 2003?
Ensure brevity in your answer.  0.97. What is the ratio of the Gross enrolment ratio (%) of Mauritania in 2001 to that in 2003?
Offer a very short reply. 0.96. What is the ratio of the Gross enrolment ratio (%) of Low & middle income in 2001 to that in 2004?
Provide a succinct answer. 0.93. What is the ratio of the Gross enrolment ratio (%) in Mauritania in 2001 to that in 2004?
Offer a very short reply. 0.93. What is the ratio of the Gross enrolment ratio (%) of Low & middle income in 2001 to that in 2005?
Your answer should be very brief. 0.92. What is the ratio of the Gross enrolment ratio (%) of Georgia in 2001 to that in 2005?
Provide a short and direct response. 0.97. What is the ratio of the Gross enrolment ratio (%) of Mauritania in 2001 to that in 2005?
Keep it short and to the point. 0.92. What is the ratio of the Gross enrolment ratio (%) in Low & middle income in 2001 to that in 2006?
Your answer should be compact. 0.89. What is the ratio of the Gross enrolment ratio (%) in Georgia in 2001 to that in 2006?
Ensure brevity in your answer.  0.95. What is the ratio of the Gross enrolment ratio (%) of Korea (Republic) in 2001 to that in 2006?
Keep it short and to the point. 1.01. What is the ratio of the Gross enrolment ratio (%) in Mauritania in 2001 to that in 2006?
Provide a succinct answer. 0.88. What is the ratio of the Gross enrolment ratio (%) in Low & middle income in 2002 to that in 2003?
Give a very brief answer. 0.98. What is the ratio of the Gross enrolment ratio (%) of Georgia in 2002 to that in 2003?
Provide a short and direct response. 0.98. What is the ratio of the Gross enrolment ratio (%) in Korea (Republic) in 2002 to that in 2003?
Your answer should be compact. 1. What is the ratio of the Gross enrolment ratio (%) in Low & middle income in 2002 to that in 2004?
Offer a terse response. 0.95. What is the ratio of the Gross enrolment ratio (%) of Georgia in 2002 to that in 2004?
Your answer should be compact. 1.02. What is the ratio of the Gross enrolment ratio (%) of Mauritania in 2002 to that in 2004?
Make the answer very short. 0.93. What is the ratio of the Gross enrolment ratio (%) in Low & middle income in 2002 to that in 2005?
Offer a very short reply. 0.94. What is the ratio of the Gross enrolment ratio (%) in Mauritania in 2002 to that in 2005?
Make the answer very short. 0.92. What is the ratio of the Gross enrolment ratio (%) in Low & middle income in 2002 to that in 2006?
Give a very brief answer. 0.92. What is the ratio of the Gross enrolment ratio (%) of Georgia in 2002 to that in 2006?
Your answer should be compact. 0.97. What is the ratio of the Gross enrolment ratio (%) of Korea (Republic) in 2002 to that in 2006?
Your answer should be compact. 1.01. What is the ratio of the Gross enrolment ratio (%) in Mauritania in 2002 to that in 2006?
Provide a succinct answer. 0.88. What is the ratio of the Gross enrolment ratio (%) of Low & middle income in 2003 to that in 2004?
Give a very brief answer. 0.98. What is the ratio of the Gross enrolment ratio (%) of Georgia in 2003 to that in 2004?
Keep it short and to the point. 1.04. What is the ratio of the Gross enrolment ratio (%) of Korea (Republic) in 2003 to that in 2004?
Offer a very short reply. 1. What is the ratio of the Gross enrolment ratio (%) in Mauritania in 2003 to that in 2004?
Make the answer very short. 0.97. What is the ratio of the Gross enrolment ratio (%) in Low & middle income in 2003 to that in 2005?
Your response must be concise. 0.96. What is the ratio of the Gross enrolment ratio (%) of Mauritania in 2003 to that in 2005?
Keep it short and to the point. 0.96. What is the ratio of the Gross enrolment ratio (%) of Low & middle income in 2003 to that in 2006?
Make the answer very short. 0.94. What is the ratio of the Gross enrolment ratio (%) of Georgia in 2003 to that in 2006?
Your response must be concise. 0.99. What is the ratio of the Gross enrolment ratio (%) in Korea (Republic) in 2003 to that in 2006?
Your response must be concise. 1.01. What is the ratio of the Gross enrolment ratio (%) of Mauritania in 2003 to that in 2006?
Offer a very short reply. 0.92. What is the ratio of the Gross enrolment ratio (%) in Low & middle income in 2004 to that in 2005?
Offer a very short reply. 0.98. What is the ratio of the Gross enrolment ratio (%) in Georgia in 2004 to that in 2005?
Your answer should be compact. 0.97. What is the ratio of the Gross enrolment ratio (%) in Mauritania in 2004 to that in 2005?
Give a very brief answer. 0.98. What is the ratio of the Gross enrolment ratio (%) of Low & middle income in 2004 to that in 2006?
Your response must be concise. 0.96. What is the ratio of the Gross enrolment ratio (%) in Georgia in 2004 to that in 2006?
Give a very brief answer. 0.95. What is the ratio of the Gross enrolment ratio (%) of Korea (Republic) in 2004 to that in 2006?
Offer a very short reply. 1.01. What is the ratio of the Gross enrolment ratio (%) of Mauritania in 2004 to that in 2006?
Your answer should be very brief. 0.95. What is the ratio of the Gross enrolment ratio (%) of Low & middle income in 2005 to that in 2006?
Your answer should be compact. 0.98. What is the ratio of the Gross enrolment ratio (%) of Georgia in 2005 to that in 2006?
Your answer should be very brief. 0.98. What is the ratio of the Gross enrolment ratio (%) in Korea (Republic) in 2005 to that in 2006?
Make the answer very short. 1.01. What is the ratio of the Gross enrolment ratio (%) in Mauritania in 2005 to that in 2006?
Provide a short and direct response. 0.96. What is the difference between the highest and the second highest Gross enrolment ratio (%) in Low & middle income?
Keep it short and to the point. 1.34. What is the difference between the highest and the second highest Gross enrolment ratio (%) of Georgia?
Make the answer very short. 1.24. What is the difference between the highest and the second highest Gross enrolment ratio (%) of Korea (Republic)?
Keep it short and to the point. 0.16. What is the difference between the highest and the second highest Gross enrolment ratio (%) in Mauritania?
Provide a short and direct response. 0.89. What is the difference between the highest and the lowest Gross enrolment ratio (%) in Low & middle income?
Give a very brief answer. 6.29. What is the difference between the highest and the lowest Gross enrolment ratio (%) of Georgia?
Offer a very short reply. 4.42. What is the difference between the highest and the lowest Gross enrolment ratio (%) in Korea (Republic)?
Offer a very short reply. 1.05. What is the difference between the highest and the lowest Gross enrolment ratio (%) of Mauritania?
Make the answer very short. 2.7. 